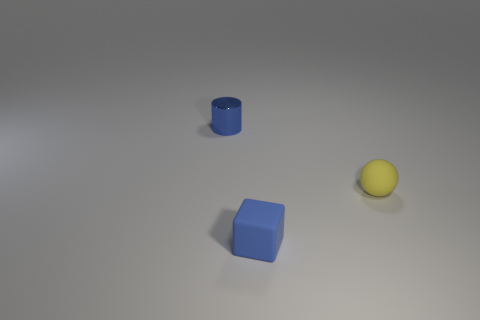Subtract all spheres. How many objects are left? 2 Add 1 small blue cylinders. How many objects exist? 4 Subtract 0 brown balls. How many objects are left? 3 Subtract 1 balls. How many balls are left? 0 Subtract all cyan cylinders. Subtract all brown spheres. How many cylinders are left? 1 Subtract all yellow rubber balls. Subtract all rubber things. How many objects are left? 0 Add 3 spheres. How many spheres are left? 4 Add 1 tiny blue matte cubes. How many tiny blue matte cubes exist? 2 